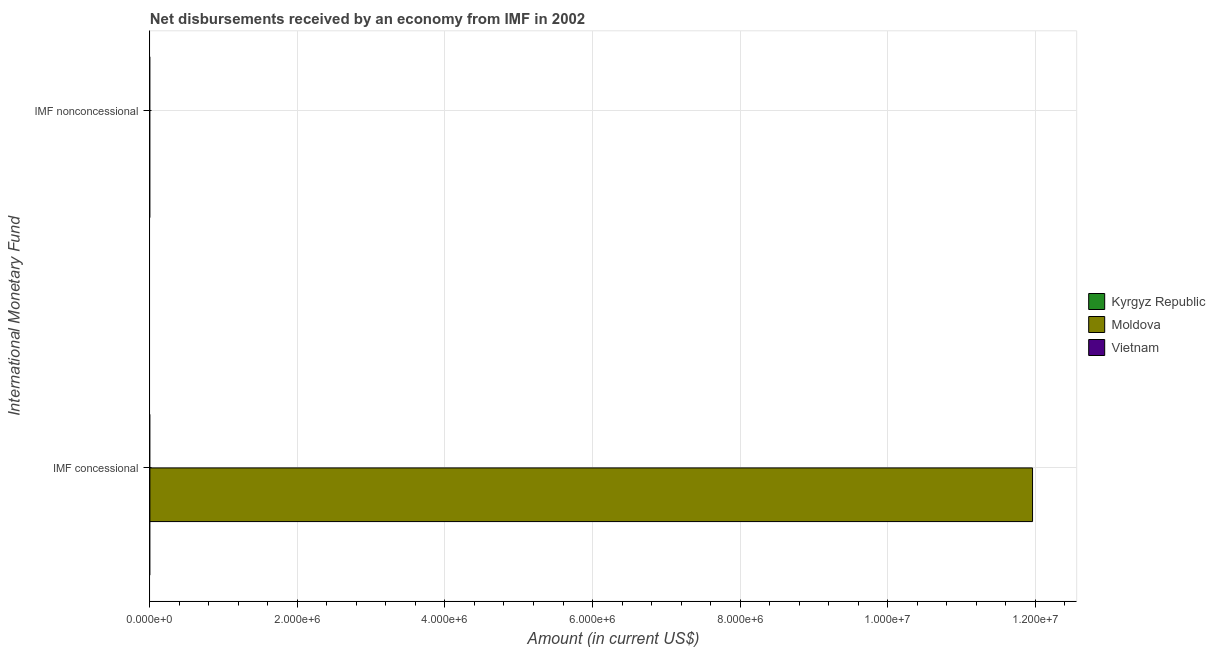Are the number of bars per tick equal to the number of legend labels?
Offer a terse response. No. Are the number of bars on each tick of the Y-axis equal?
Your answer should be compact. No. How many bars are there on the 1st tick from the top?
Your answer should be compact. 0. What is the label of the 1st group of bars from the top?
Offer a very short reply. IMF nonconcessional. Across all countries, what is the maximum net concessional disbursements from imf?
Your response must be concise. 1.20e+07. In which country was the net concessional disbursements from imf maximum?
Your answer should be compact. Moldova. What is the total net non concessional disbursements from imf in the graph?
Offer a terse response. 0. In how many countries, is the net non concessional disbursements from imf greater than the average net non concessional disbursements from imf taken over all countries?
Give a very brief answer. 0. How many countries are there in the graph?
Your answer should be compact. 3. Does the graph contain grids?
Offer a terse response. Yes. How many legend labels are there?
Offer a very short reply. 3. How are the legend labels stacked?
Offer a terse response. Vertical. What is the title of the graph?
Give a very brief answer. Net disbursements received by an economy from IMF in 2002. What is the label or title of the Y-axis?
Ensure brevity in your answer.  International Monetary Fund. What is the Amount (in current US$) in Kyrgyz Republic in IMF concessional?
Offer a terse response. 0. What is the Amount (in current US$) of Moldova in IMF concessional?
Provide a succinct answer. 1.20e+07. What is the Amount (in current US$) in Kyrgyz Republic in IMF nonconcessional?
Your answer should be compact. 0. What is the Amount (in current US$) of Moldova in IMF nonconcessional?
Provide a short and direct response. 0. Across all International Monetary Fund, what is the maximum Amount (in current US$) in Moldova?
Give a very brief answer. 1.20e+07. What is the total Amount (in current US$) of Moldova in the graph?
Your answer should be very brief. 1.20e+07. What is the average Amount (in current US$) of Moldova per International Monetary Fund?
Your answer should be compact. 5.98e+06. What is the difference between the highest and the lowest Amount (in current US$) in Moldova?
Provide a short and direct response. 1.20e+07. 